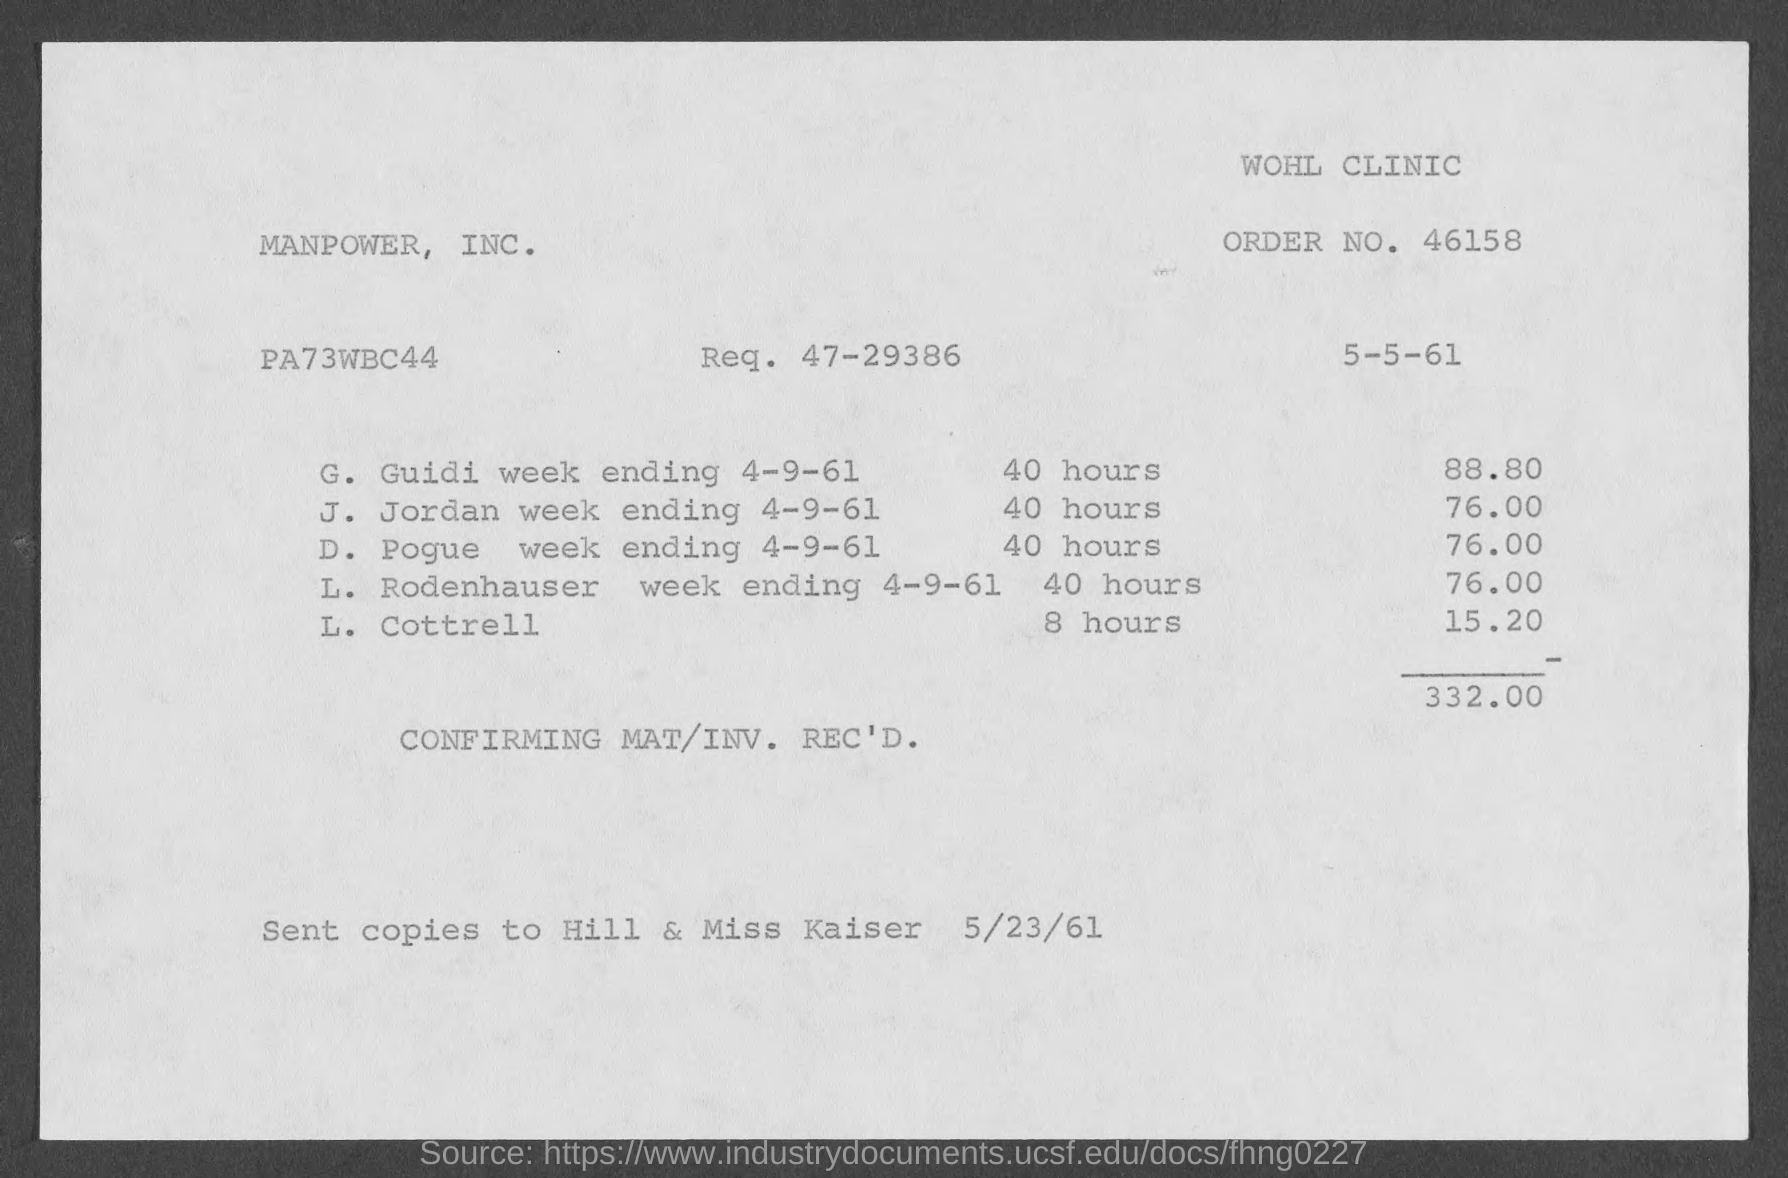What is the order no.?
Your response must be concise. 46158. What is the req. no.?
Offer a very short reply. 47-29386. What is the name of the clinic?
Offer a very short reply. Wohl clinic. 